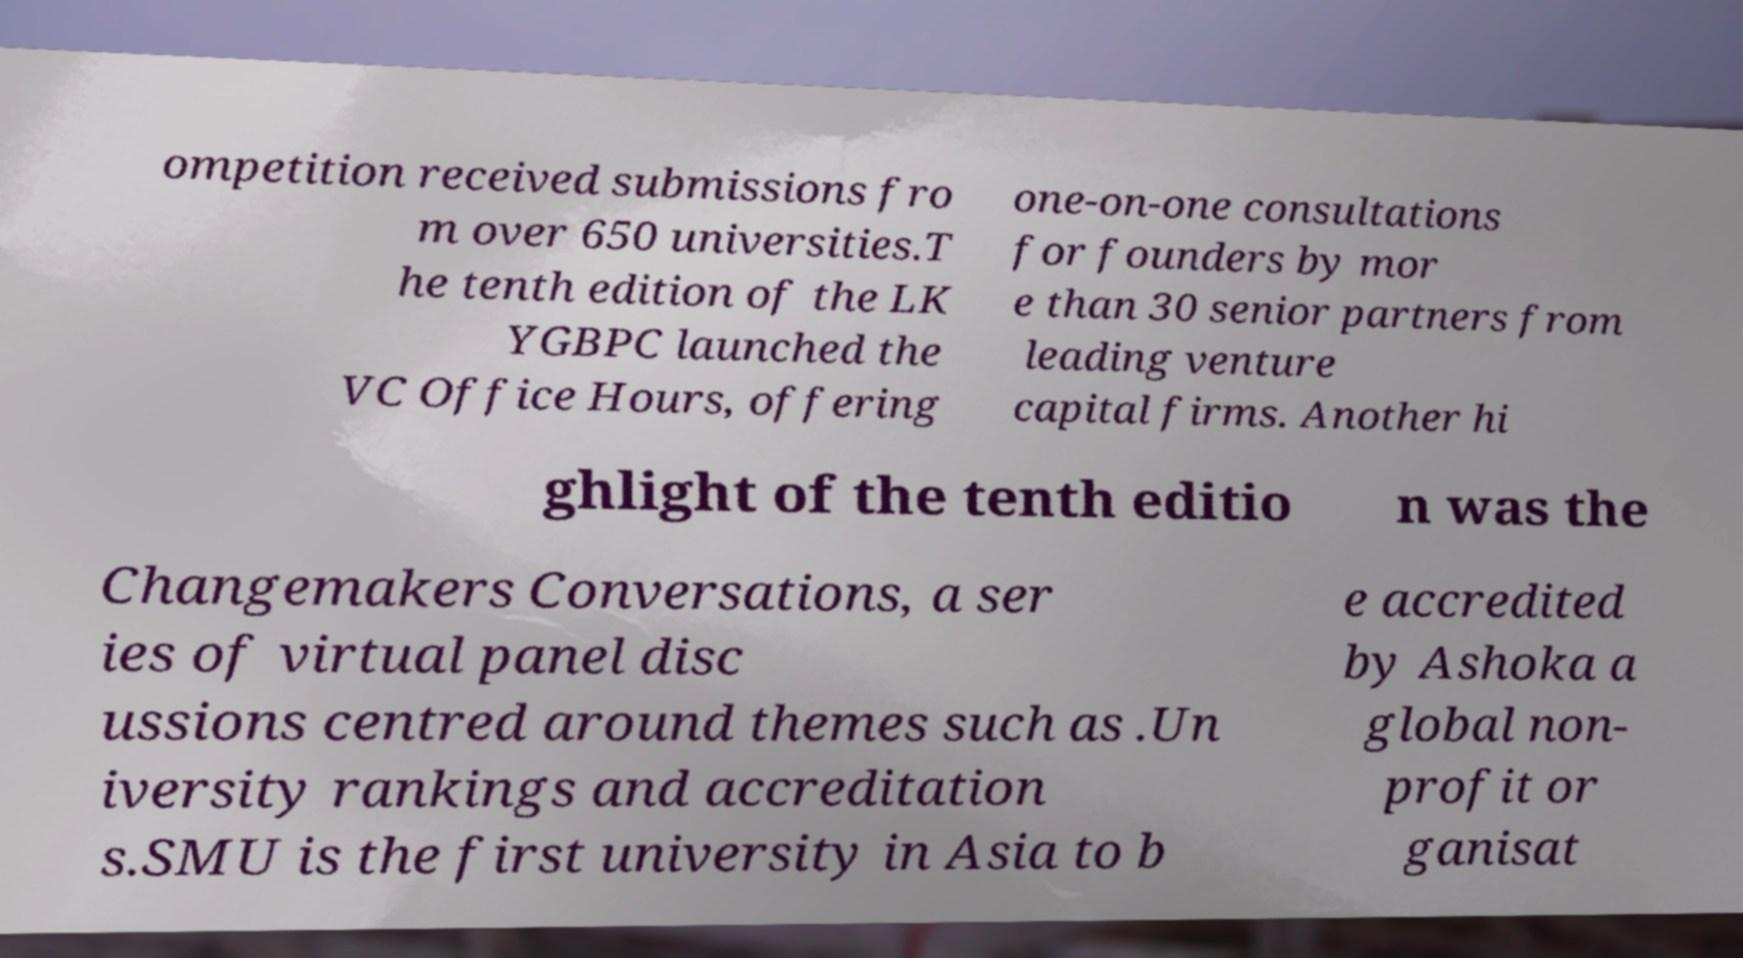Please identify and transcribe the text found in this image. ompetition received submissions fro m over 650 universities.T he tenth edition of the LK YGBPC launched the VC Office Hours, offering one-on-one consultations for founders by mor e than 30 senior partners from leading venture capital firms. Another hi ghlight of the tenth editio n was the Changemakers Conversations, a ser ies of virtual panel disc ussions centred around themes such as .Un iversity rankings and accreditation s.SMU is the first university in Asia to b e accredited by Ashoka a global non- profit or ganisat 